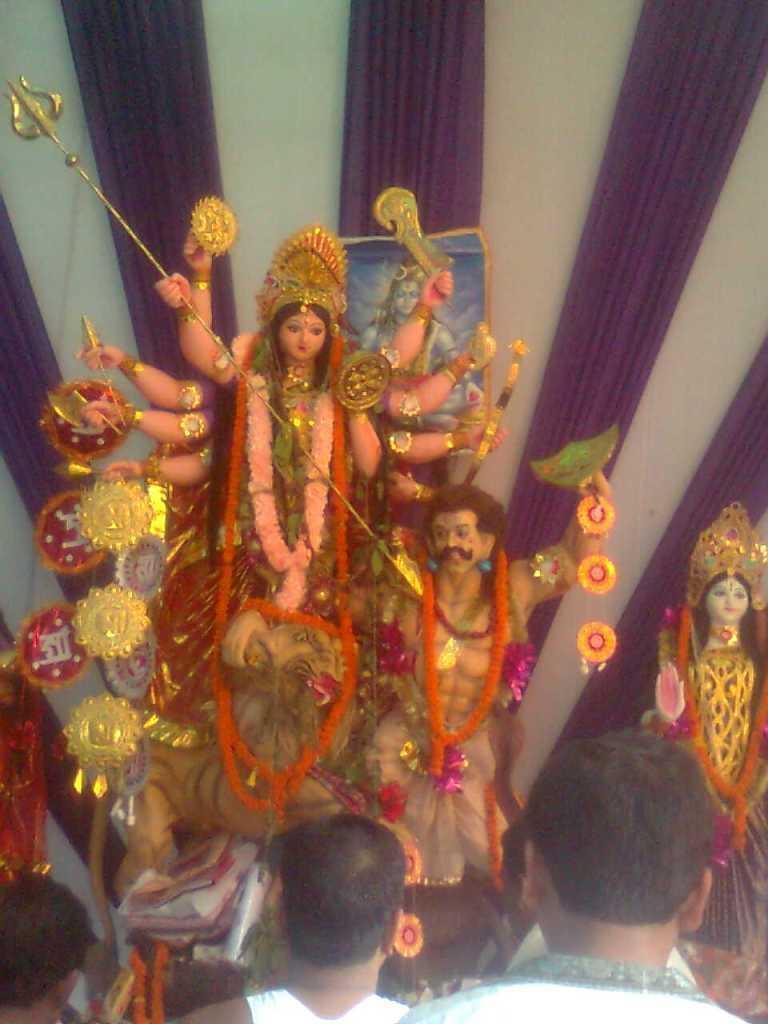How would you summarize this image in a sentence or two? In this image we can see idols with garlands. At the bottom there are few people. In the background we can see curtains. 